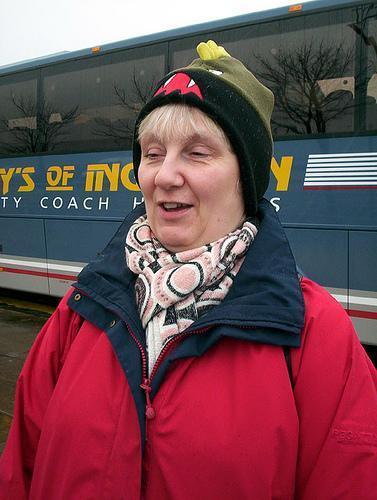Verify the accuracy of this image caption: "The person is inside the bus.".
Answer yes or no. No. 